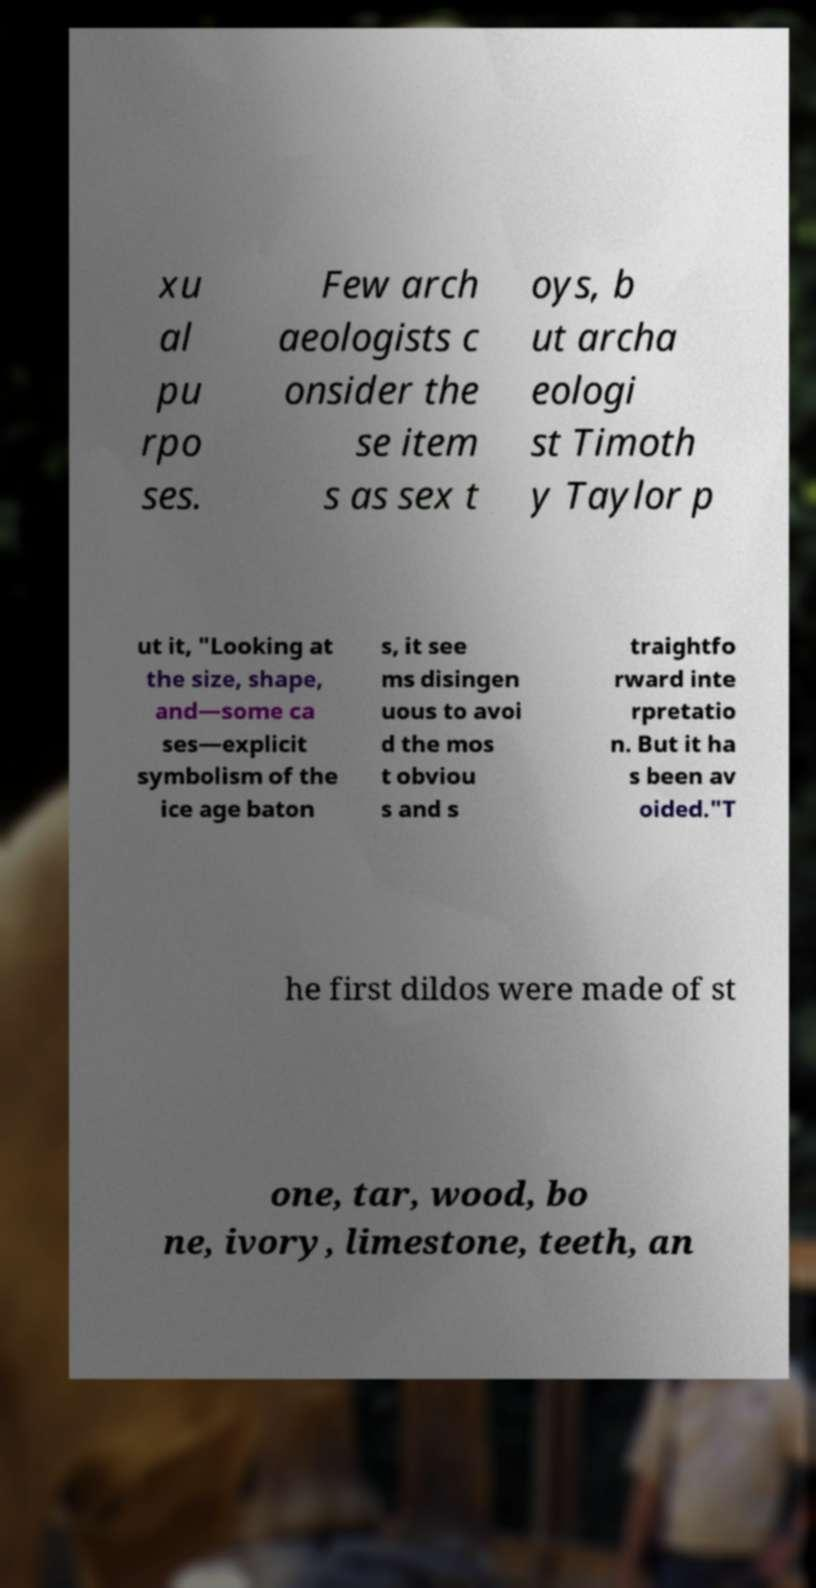Please identify and transcribe the text found in this image. xu al pu rpo ses. Few arch aeologists c onsider the se item s as sex t oys, b ut archa eologi st Timoth y Taylor p ut it, "Looking at the size, shape, and—some ca ses—explicit symbolism of the ice age baton s, it see ms disingen uous to avoi d the mos t obviou s and s traightfo rward inte rpretatio n. But it ha s been av oided."T he first dildos were made of st one, tar, wood, bo ne, ivory, limestone, teeth, an 